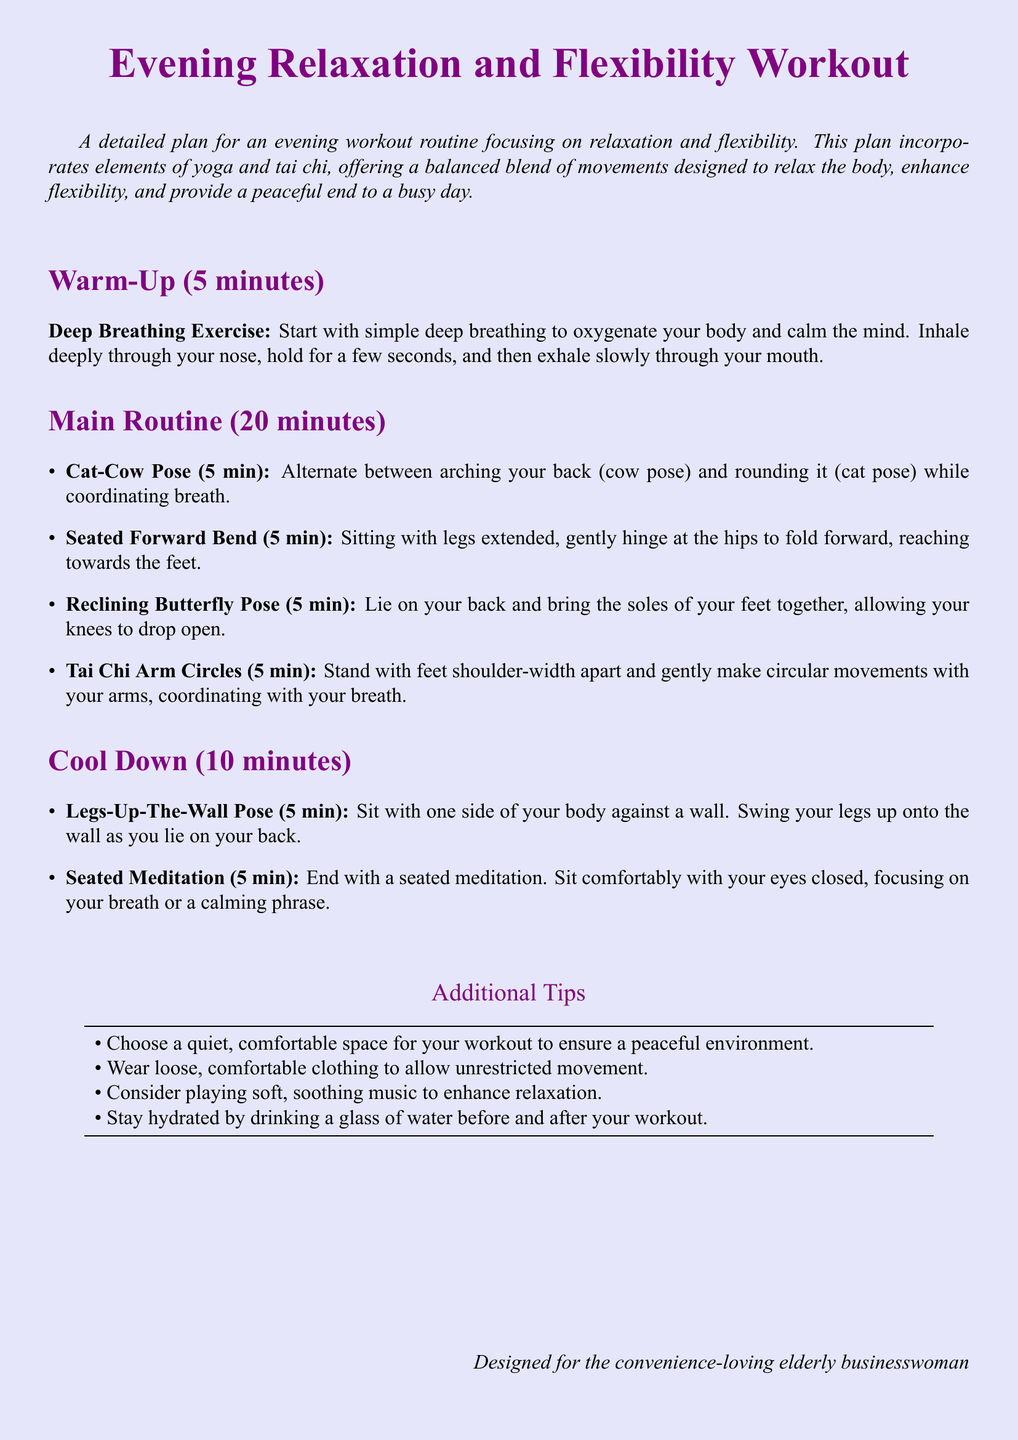What is the duration of the warm-up? The warm-up section states that it lasts for 5 minutes.
Answer: 5 minutes How many minutes is the main routine? The main routine totals to 20 minutes as specified in the document.
Answer: 20 minutes What is the first exercise in the main routine? The first exercise listed is the Cat-Cow Pose in the main routine.
Answer: Cat-Cow Pose How long should you perform the Seated Meditation during cool down? The document indicates that the Seated Meditation should be performed for 5 minutes.
Answer: 5 minutes What is one of the additional tips provided? The document mentions multiple tips; one is about choosing a quiet, comfortable space for your workout.
Answer: Choose a quiet, comfortable space What type of workout does this plan focus on? The plan focuses on relaxation and flexibility as noted in the introduction.
Answer: Relaxation and flexibility How many main exercises are listed in the document? There are four main exercises listed in the main routine section.
Answer: Four What pose is done with legs elevated against the wall? The document specifies the pose as Legs-Up-The-Wall Pose during the cool down.
Answer: Legs-Up-The-Wall Pose 